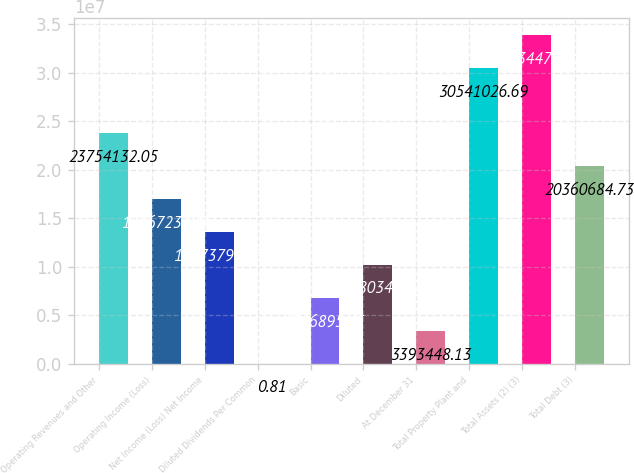Convert chart. <chart><loc_0><loc_0><loc_500><loc_500><bar_chart><fcel>Operating Revenues and Other<fcel>Operating Income (Loss)<fcel>Net Income (Loss) Net Income<fcel>Diluted Dividends Per Common<fcel>Basic<fcel>Diluted<fcel>At December 31<fcel>Total Property Plant and<fcel>Total Assets (2) (3)<fcel>Total Debt (3)<nl><fcel>2.37541e+07<fcel>1.69672e+07<fcel>1.35738e+07<fcel>0.81<fcel>6.7869e+06<fcel>1.01803e+07<fcel>3.39345e+06<fcel>3.0541e+07<fcel>3.39345e+07<fcel>2.03607e+07<nl></chart> 